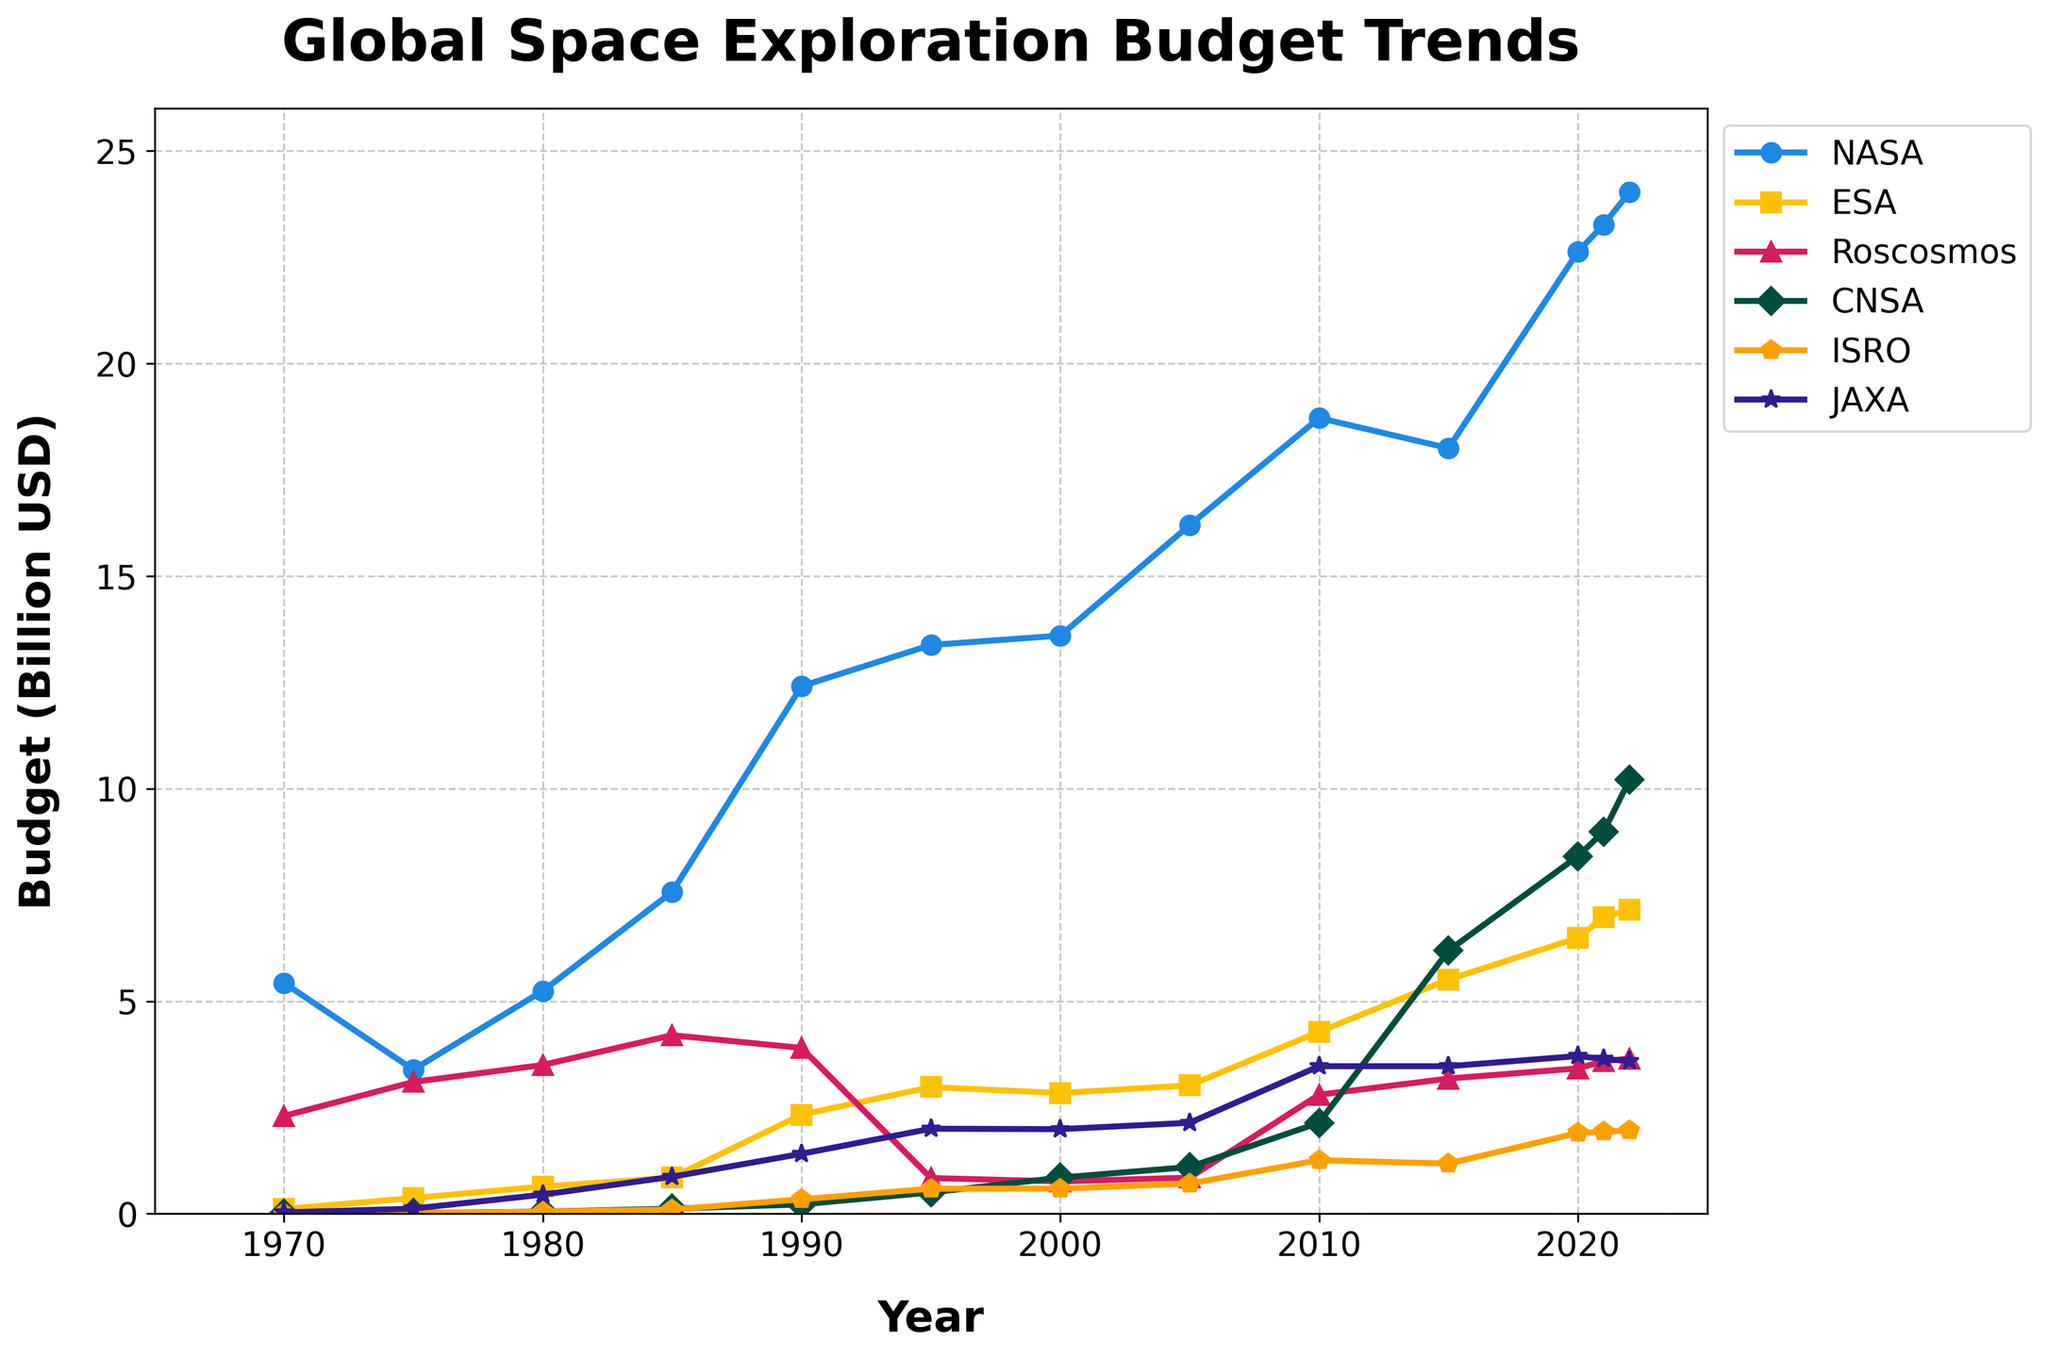What's the trend in NASA's budget over the past 50 years? Looking at the line for NASA, it starts at 5.43 billion USD in 1970 and gradually increases over the years, reaching 24.04 billion USD in 2022.
Answer: Increased trend At which year did CNSA's budget see a significant rise? Observing the line representing CNSA, there's a noticeable sharp increase around the year 2015, jumping from 2.14 billion USD in 2010 to 6.19 billion USD in 2015.
Answer: 2015 Which space agency had the highest budget in 2022? By examining the endpoints of all the lines in 2022, it's clear that NASA's line is at the top with a budget of 24.04 billion USD, making it the highest that year.
Answer: NASA How does ESA's budget in 1990 compare to its budget in 2022? ESA's budget in 1990 is 2.33 billion USD. In 2022, it rose to 7.15 billion USD. The difference is 7.15 - 2.33 = 4.82 billion USD.
Answer: ESA's budget increased by 4.82 billion USD In which year did JAXA's budget exceed 3 billion USD for the first time? The JAXA line crosses the 3 billion USD mark between 2005 and 2010, with its budget at 3.47 billion USD in 2010.
Answer: 2010 What's the average budget of ISRO between 2010 and 2022? To find the average: (1.26 in 2010 + 1.18 in 2015 + 1.90 in 2020 + 1.93 in 2021 + 1.96 in 2022) / 5. The sum of ISRO budgets over these years is 8.23 billion USD, so the average is 8.23 / 5 = 1.646 billion USD.
Answer: 1.65 billion USD (approx.) Which two agencies had almost equal budgets in 2015, and what was the approximate value? In the year 2015, ESA and JAXA have almost identical budgets, with ESA at 5.51 billion USD and JAXA at 3.47 billion USD.
Answer: ESA and JAXA, around 3.5 billion USD Did Roscosmos's budget decrease or increase between 1990 and 1995? By comparing the values from the line plot, Roscosmos's budget decreased from 3.90 billion USD in 1990 to 0.84 billion USD in 1995.
Answer: Decrease What is the difference between the highest and lowest recorded budgets for CNSA throughout the years? CNSA's highest budget is 10.21 billion USD in 2022 and its lowest is 0.01 billion USD in 1970. The difference is 10.21 - 0.01 = 10.20 billion USD.
Answer: 10.20 billion USD Which space agency showed the least fluctuation in its budget over the 50 years? By observing the smoothness and range of the budget lines, ISRO remains relatively stable with gradual increases, unlike more volatile budgets like Roscosmos and NASA.
Answer: ISRO 